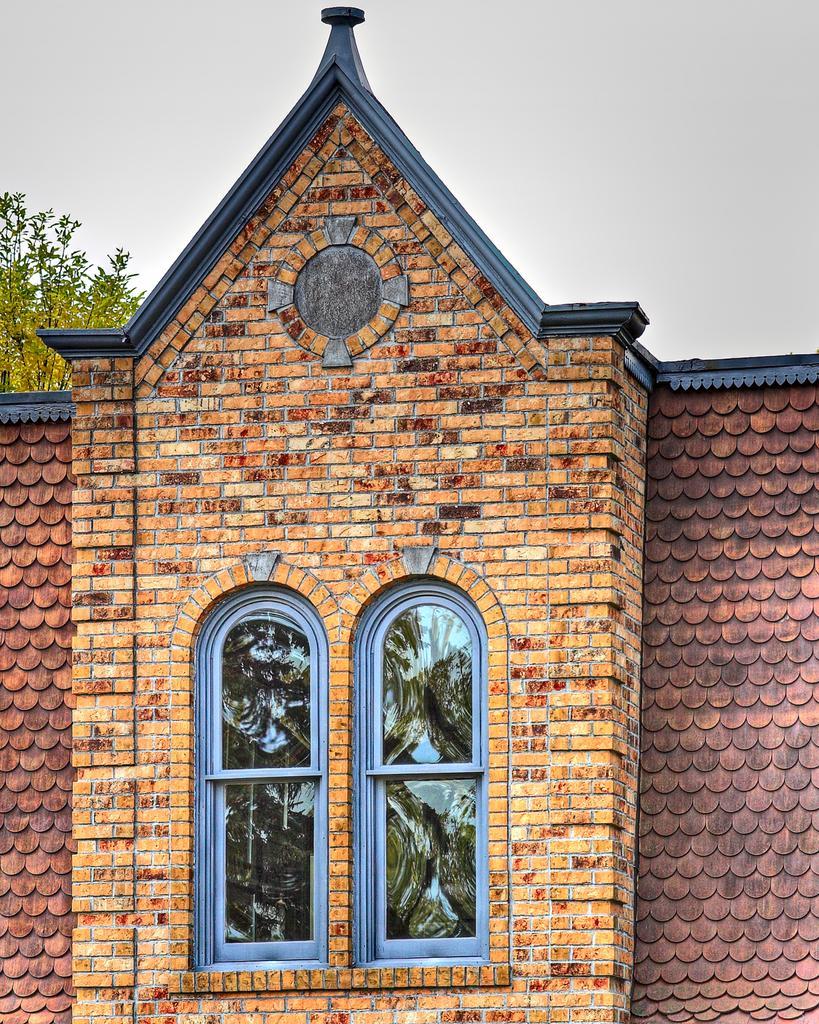In one or two sentences, can you explain what this image depicts? In this image we can see a house, windows, tree, and the sky. 